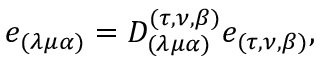Convert formula to latex. <formula><loc_0><loc_0><loc_500><loc_500>e _ { ( \lambda \mu \alpha ) } = D _ { ( \lambda \mu \alpha ) } ^ { ( \tau , \nu , \beta ) } e _ { ( \tau , \nu , \beta ) } ,</formula> 